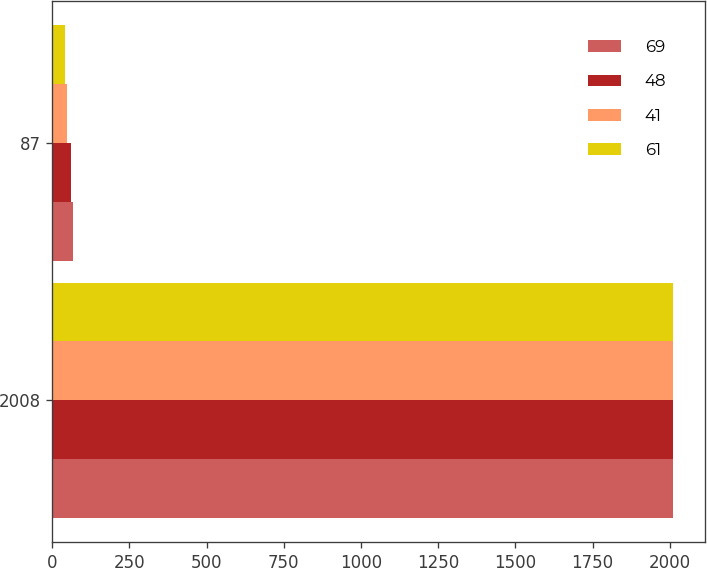Convert chart. <chart><loc_0><loc_0><loc_500><loc_500><stacked_bar_chart><ecel><fcel>2008<fcel>87<nl><fcel>69<fcel>2009<fcel>69<nl><fcel>48<fcel>2010<fcel>61<nl><fcel>41<fcel>2011<fcel>48<nl><fcel>61<fcel>2012<fcel>41<nl></chart> 